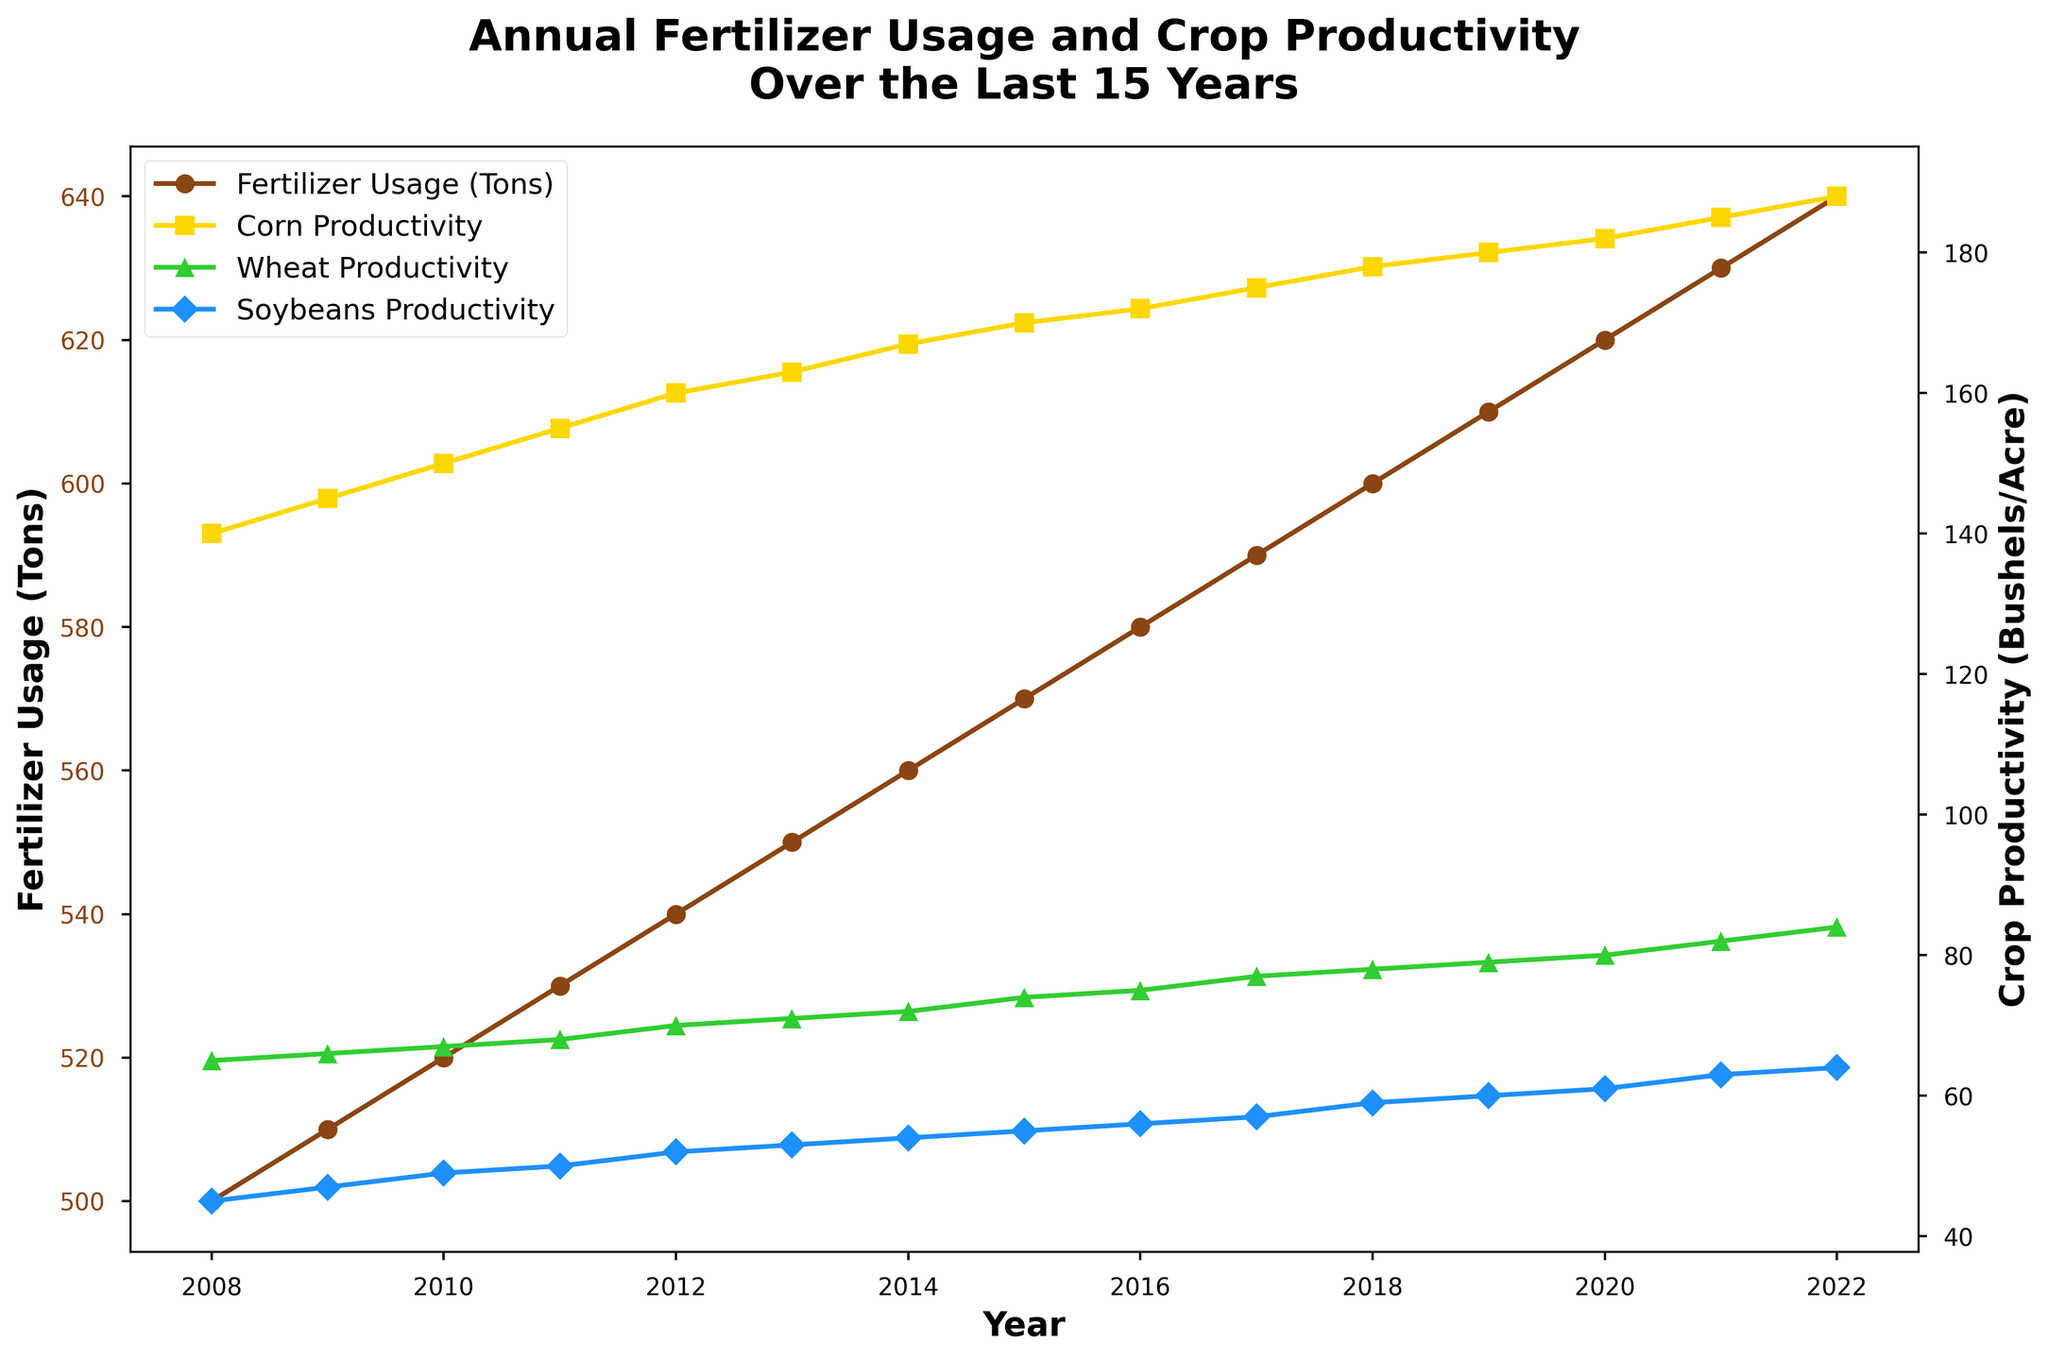What is the title of the figure? The title is located at the top center of the figure in bold. It reads, "Annual Fertilizer Usage and Crop Productivity Over the Last 15 Years."
Answer: Annual Fertilizer Usage and Crop Productivity Over the Last 15 Years How many years of data are presented in the figure? The x-axis represents the year, and the data points start at 2008 and go through to 2022. Counting each year in this range totals 15 years.
Answer: 15 years What are the labels of the two y-axes in the figure? The figure uses a dual-axis plot. The left y-axis labeled "Fertilizer Usage (Tons)" is for the fertilizer usage line, while the right y-axis labeled "Crop Productivity (Bushels/Acre)" is for the crop productivity lines.
Answer: Fertilizer Usage (Tons) and Crop Productivity (Bushels/Acre) What color is the line representing Corn Productivity? The line representing Corn Productivity is plotted in yellow, a color akin to what corn might look like.
Answer: Yellow By how much did Soybeans Productivity increase from 2009 to 2012? In 2009, Soybeans Productivity was 47 Bushels/Acre. By 2012, it increased to 52 Bushels/Acre. The change is 52 - 47.
Answer: 5 Bushels/Acre Which crop showed the highest productivity in 2018? To find the highest productivity for 2018, we compare the three crop lines at that year. Corn Productivity is 178, Wheat Productivity is 78, and Soybeans Productivity is 59. Corn has the highest productivity.
Answer: Corn How much fertilizer was used in 2016, and what was the corresponding Corn Productivity? In the figure, for the year 2016, the fertilizer usage was 580 Tons and the Corn Productivity was 172 Bushels/Acre.
Answer: 580 Tons and 172 Bushels/Acre Compare the annual trend of Fertilizer Usage to Wheat Productivity from 2008 to 2022. Both Fertilizer Usage and Wheat Productivity show an upward trend from 2008 to 2022. Fertilizer Usage increases steadily from 500 to 640 Tons, while Wheat Productivity rises from 65 to 84 Bushels/Acre.
Answer: Both increase What is the average annual increase in Fertilizer Usage over the last 15 years? Fertilizer usage in 2008 was 500 Tons and in 2022 it was 640 Tons. The total increase over 15 years is 640 - 500 = 140 Tons. The average annual increase is 140 / 15.
Answer: 9.33 Tons per year 